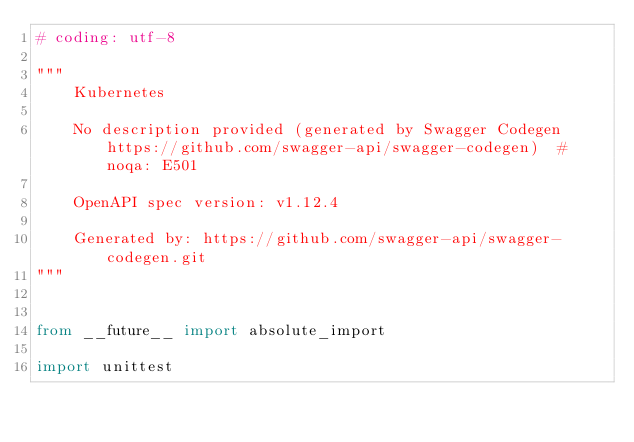Convert code to text. <code><loc_0><loc_0><loc_500><loc_500><_Python_># coding: utf-8

"""
    Kubernetes

    No description provided (generated by Swagger Codegen https://github.com/swagger-api/swagger-codegen)  # noqa: E501

    OpenAPI spec version: v1.12.4
    
    Generated by: https://github.com/swagger-api/swagger-codegen.git
"""


from __future__ import absolute_import

import unittest
</code> 